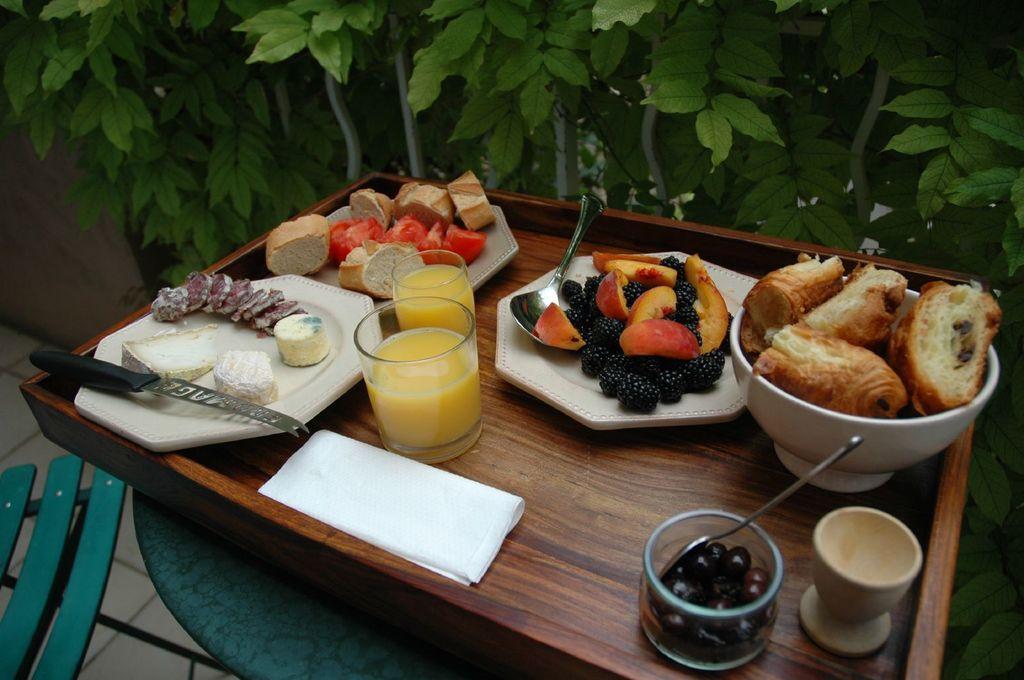In one or two sentences, can you explain what this image depicts? In this image I can see a table on which there are plates, fruits, glasses, cups, bowl and food items. In the background I can see a fence and trees. This image is taken in a lawn during a day. 